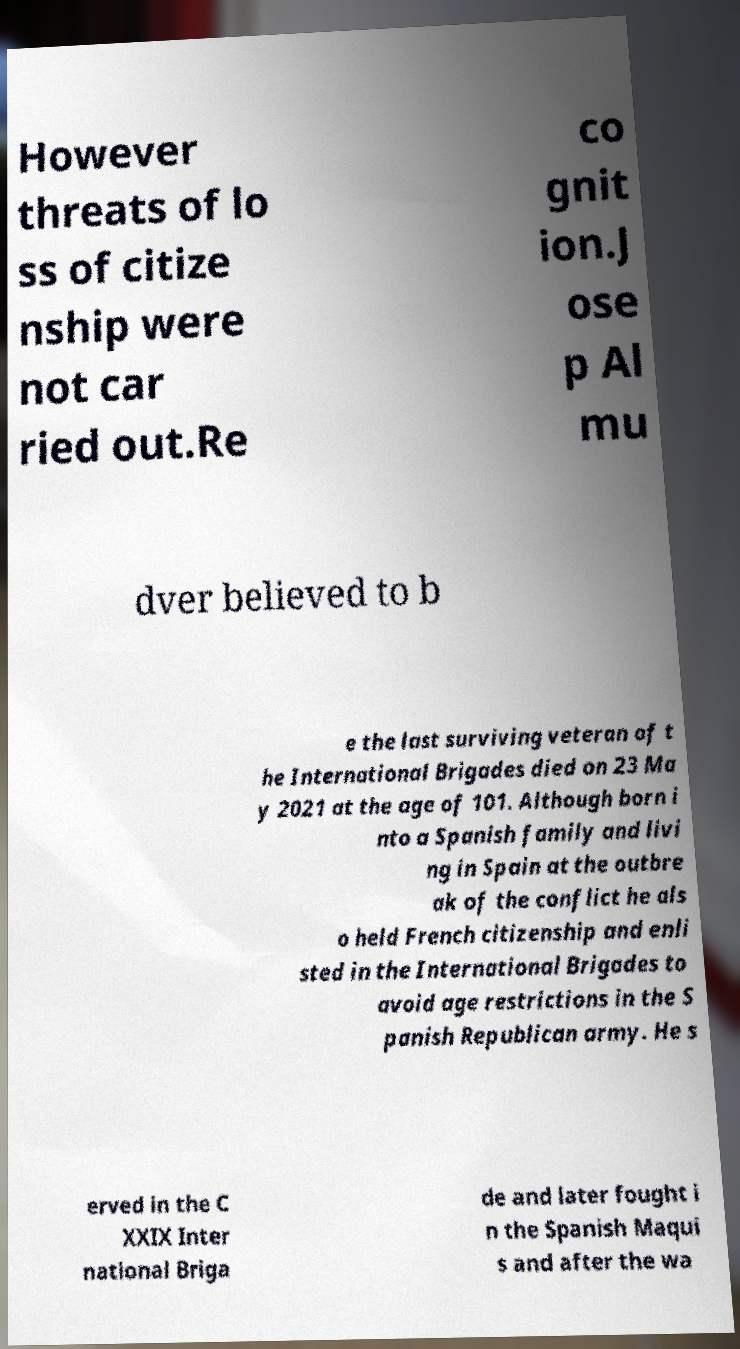I need the written content from this picture converted into text. Can you do that? However threats of lo ss of citize nship were not car ried out.Re co gnit ion.J ose p Al mu dver believed to b e the last surviving veteran of t he International Brigades died on 23 Ma y 2021 at the age of 101. Although born i nto a Spanish family and livi ng in Spain at the outbre ak of the conflict he als o held French citizenship and enli sted in the International Brigades to avoid age restrictions in the S panish Republican army. He s erved in the C XXIX Inter national Briga de and later fought i n the Spanish Maqui s and after the wa 